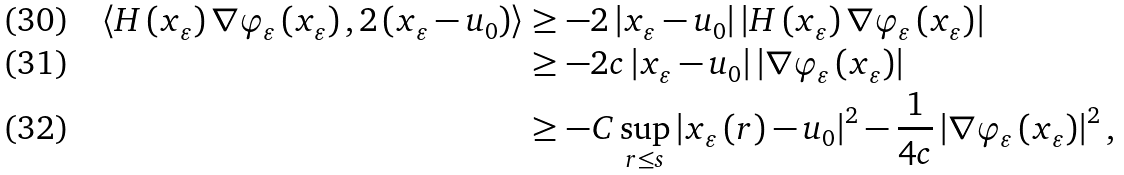Convert formula to latex. <formula><loc_0><loc_0><loc_500><loc_500>\left \langle H \left ( x _ { \varepsilon } \right ) \nabla \varphi _ { \varepsilon } \left ( x _ { \varepsilon } \right ) , 2 \left ( x _ { \varepsilon } - u _ { 0 } \right ) \right \rangle & \geq - 2 \left | x _ { \varepsilon } - u _ { 0 } \right | \left | H \left ( x _ { \varepsilon } \right ) \nabla \varphi _ { \varepsilon } \left ( x _ { \varepsilon } \right ) \right | \\ & \geq - 2 c \left | x _ { \varepsilon } - u _ { 0 } \right | \left | \nabla \varphi _ { \varepsilon } \left ( x _ { \varepsilon } \right ) \right | \\ & \geq - C \sup _ { r \leq s } \left | x _ { \varepsilon } \left ( r \right ) - u _ { 0 } \right | ^ { 2 } - \frac { 1 } { 4 c } \left | \nabla \varphi _ { \varepsilon } \left ( x _ { \varepsilon } \right ) \right | ^ { 2 } ,</formula> 